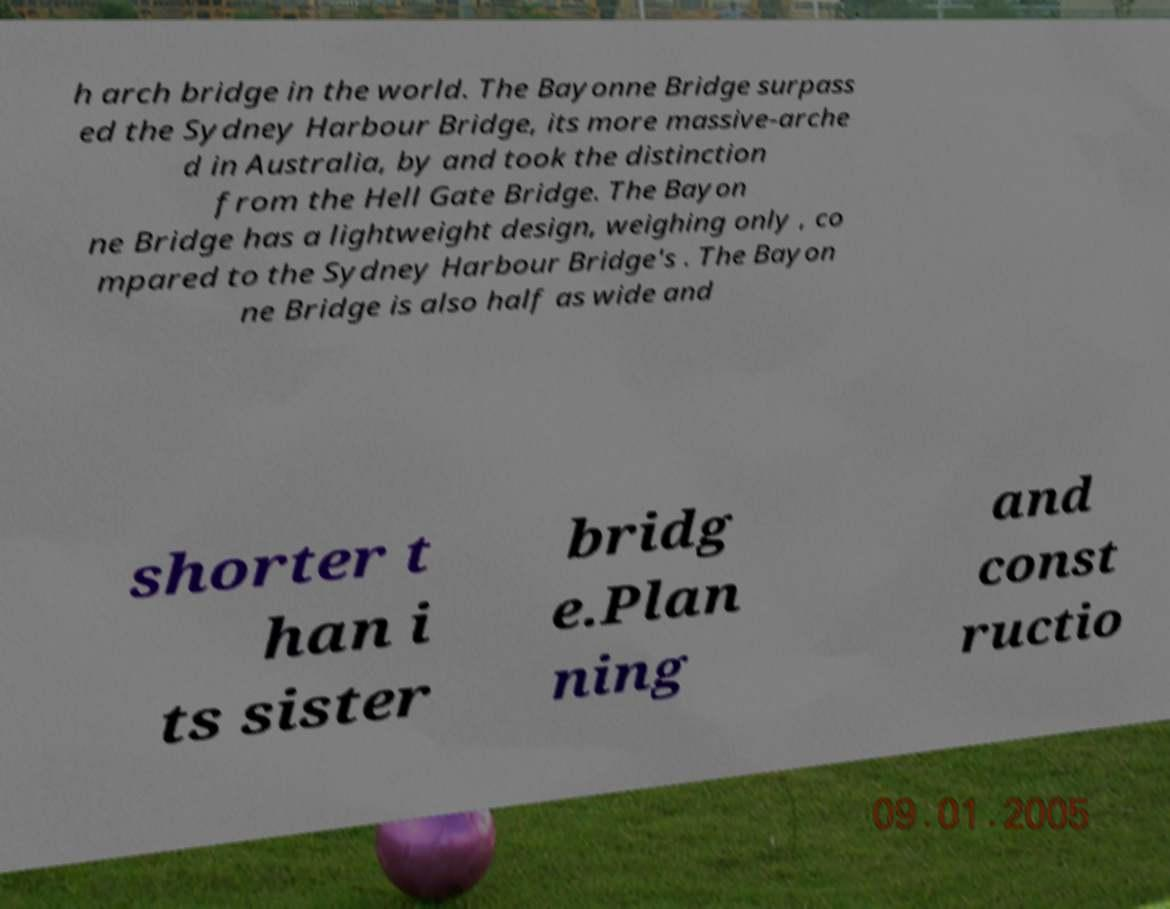Could you assist in decoding the text presented in this image and type it out clearly? h arch bridge in the world. The Bayonne Bridge surpass ed the Sydney Harbour Bridge, its more massive-arche d in Australia, by and took the distinction from the Hell Gate Bridge. The Bayon ne Bridge has a lightweight design, weighing only , co mpared to the Sydney Harbour Bridge's . The Bayon ne Bridge is also half as wide and shorter t han i ts sister bridg e.Plan ning and const ructio 